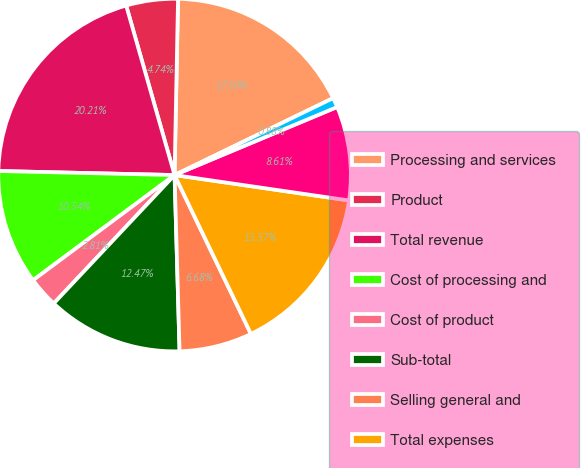<chart> <loc_0><loc_0><loc_500><loc_500><pie_chart><fcel>Processing and services<fcel>Product<fcel>Total revenue<fcel>Cost of processing and<fcel>Cost of product<fcel>Sub-total<fcel>Selling general and<fcel>Total expenses<fcel>Operating income<fcel>Interest expense<nl><fcel>17.5%<fcel>4.74%<fcel>20.21%<fcel>10.54%<fcel>2.81%<fcel>12.47%<fcel>6.68%<fcel>15.57%<fcel>8.61%<fcel>0.88%<nl></chart> 